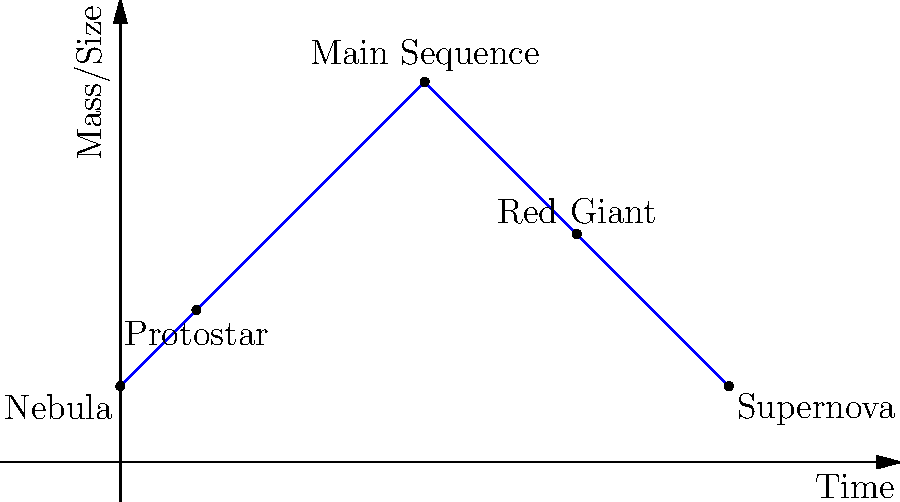In the stellar lifecycle diagram above, which stage marks the longest period in a star's life, and what fundamental process sustains the star during this phase? To answer this question, let's analyze the stellar lifecycle diagram step-by-step:

1. The diagram shows the evolution of a star from a nebula to a supernova.

2. The x-axis represents time, while the y-axis represents mass/size.

3. We can identify five key stages in the diagram:
   a) Nebula
   b) Protostar
   c) Main Sequence
   d) Red Giant
   e) Supernova

4. The Main Sequence stage is represented by the highest and widest part of the curve, indicating it's the longest-lasting stage in a star's life.

5. During the Main Sequence stage, stars are in hydrostatic equilibrium, where the outward pressure from nuclear fusion in the core balances the inward gravitational force.

6. The fundamental process sustaining stars during the Main Sequence is nuclear fusion, specifically the proton-proton chain reaction for stars like our Sun.

7. In this process, hydrogen nuclei (protons) fuse to form helium nuclei, releasing a tremendous amount of energy according to Einstein's famous equation: $E = mc^2$.

8. The energy released by nuclear fusion provides the outward pressure that prevents the star from collapsing under its own gravity, allowing it to remain stable for billions of years.
Answer: Main Sequence; nuclear fusion of hydrogen into helium 